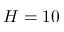<formula> <loc_0><loc_0><loc_500><loc_500>H = 1 0</formula> 